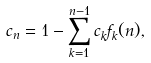Convert formula to latex. <formula><loc_0><loc_0><loc_500><loc_500>c _ { n } = 1 - \sum _ { k = 1 } ^ { n - 1 } c _ { k } f _ { k } ( n ) ,</formula> 